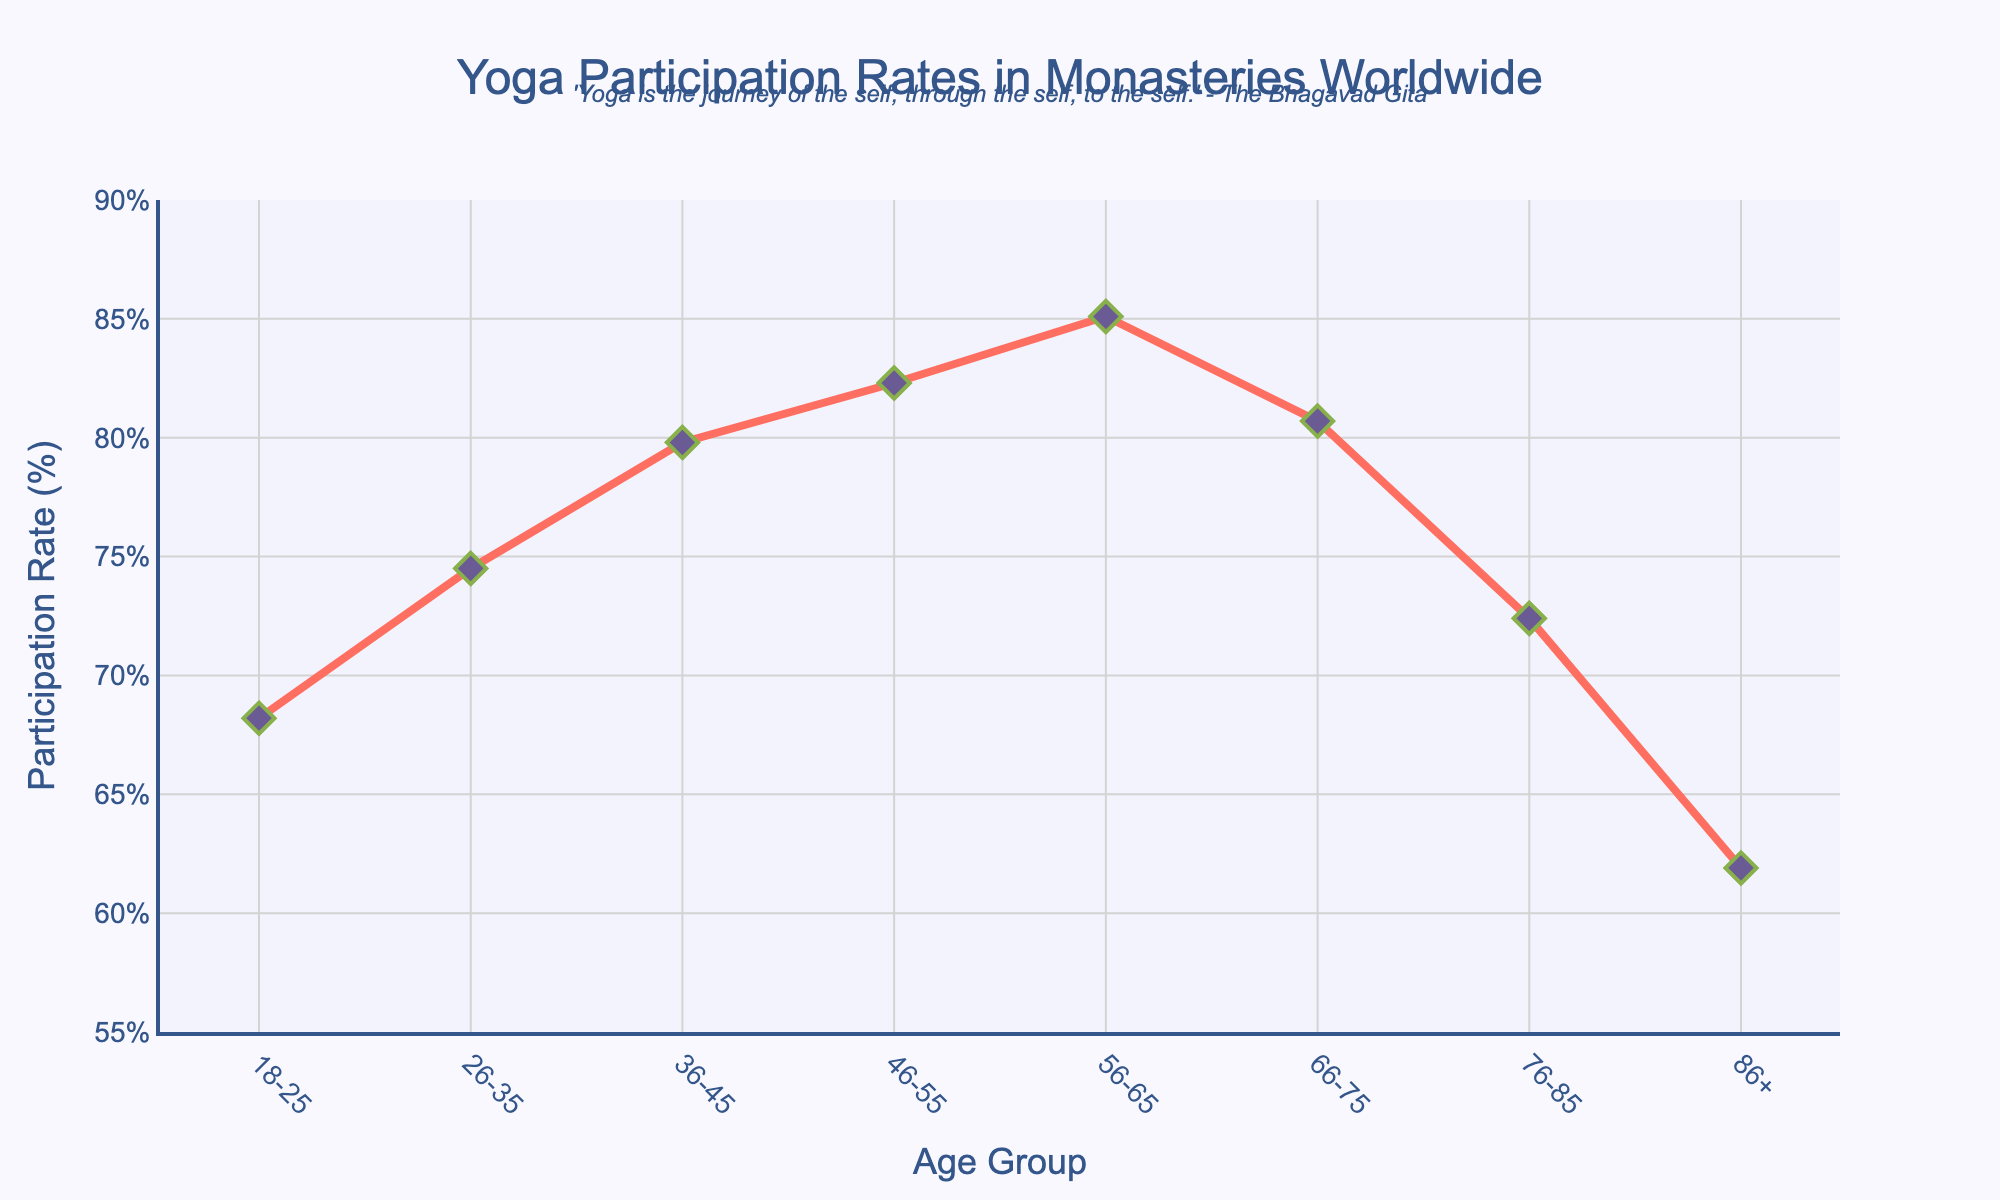What is the highest yoga participation rate across all age groups? The highest participation rate is 85.1%, which appears in the age group 56-65.
Answer: 85.1% Which age group has the lowest yoga participation rate? The lowest participation rate is 61.9%, observed in the age group 86+.
Answer: 86+ How does the yoga participation rate for the age group 46-55 compare to that of the 76-85 age group? The participation rate for the age group 46-55 is 82.3%, which is 9.9% higher than the rate for the 76-85 age group, which is 72.4%.
Answer: 46-55 is 9.9% higher By how much does the participation rate for the 36-45 age group exceed that of the 18-25 age group? The participation rate for the 36-45 age group is 79.8%, and for the 18-25 age group, it is 68.2%. The difference is 79.8% - 68.2% = 11.6%.
Answer: 11.6% What is the combined participation rate for the age groups 56-65 and 66-75? The participation rate for 56-65 is 85.1% and for 66-75 is 80.7%. The combined rate is 85.1% + 80.7% = 165.8%.
Answer: 165.8% What trend can be observed in yoga participation rates as age increases from 18-25 to 56-65? The yoga participation rate increases steadily from 68.2% in the 18-25 age group to 85.1% in the 56-65 age group. This suggests a positive trend with increasing age up to 56-65.
Answer: Increases steadily What is the visual difference in the marker style used to represent data points in the plot? The data points are represented by diamond-shaped markers that are purple with green outlines.
Answer: Diamond-shaped, purple with green outlines Which age groups experience a decline in yoga participation rates after peaking? The participation rate peaks at 85.1% in the 56-65 age group and then declines for the 66-75, 76-85, and 86+ age groups.
Answer: 66-75, 76-85, 86+ 